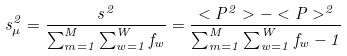Convert formula to latex. <formula><loc_0><loc_0><loc_500><loc_500>s _ { \mu } ^ { 2 } = \frac { s ^ { 2 } } { { \sum _ { m = 1 } ^ { M } \sum _ { w = 1 } ^ { W } f _ { w } } } = \frac { < P ^ { 2 } > - < P > ^ { 2 } } { { \sum _ { m = 1 } ^ { M } \sum _ { w = 1 } ^ { W } f _ { w } } - 1 }</formula> 